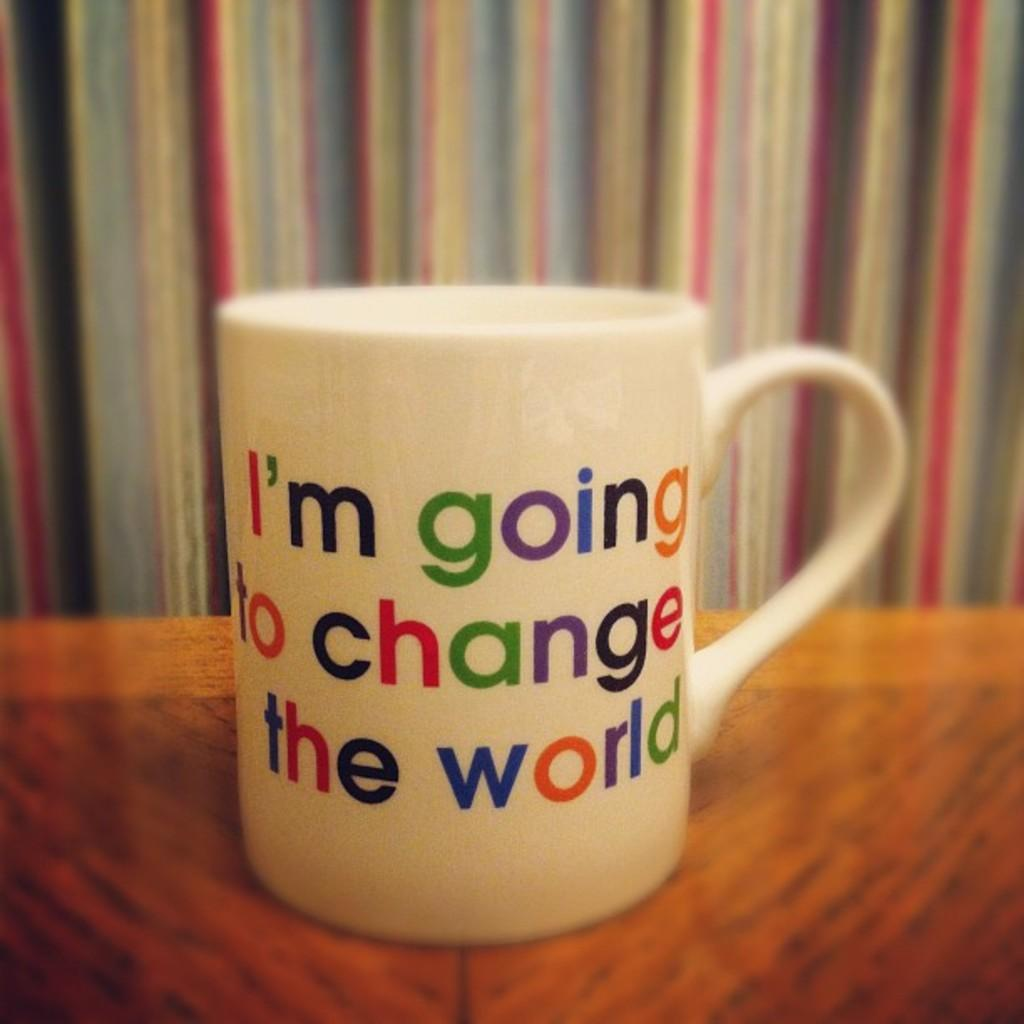Provide a one-sentence caption for the provided image. A mug that says I'm going to change the world. 